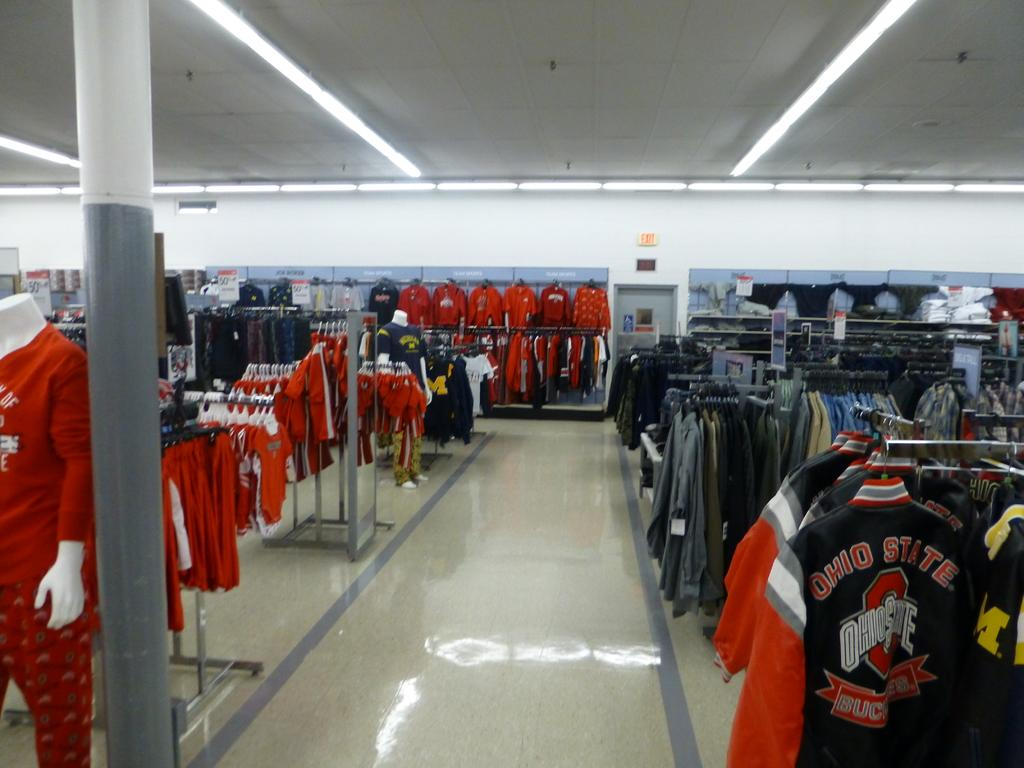<image>
Share a concise interpretation of the image provided. A clothing store displays some Ohio State apparel on its racks. 